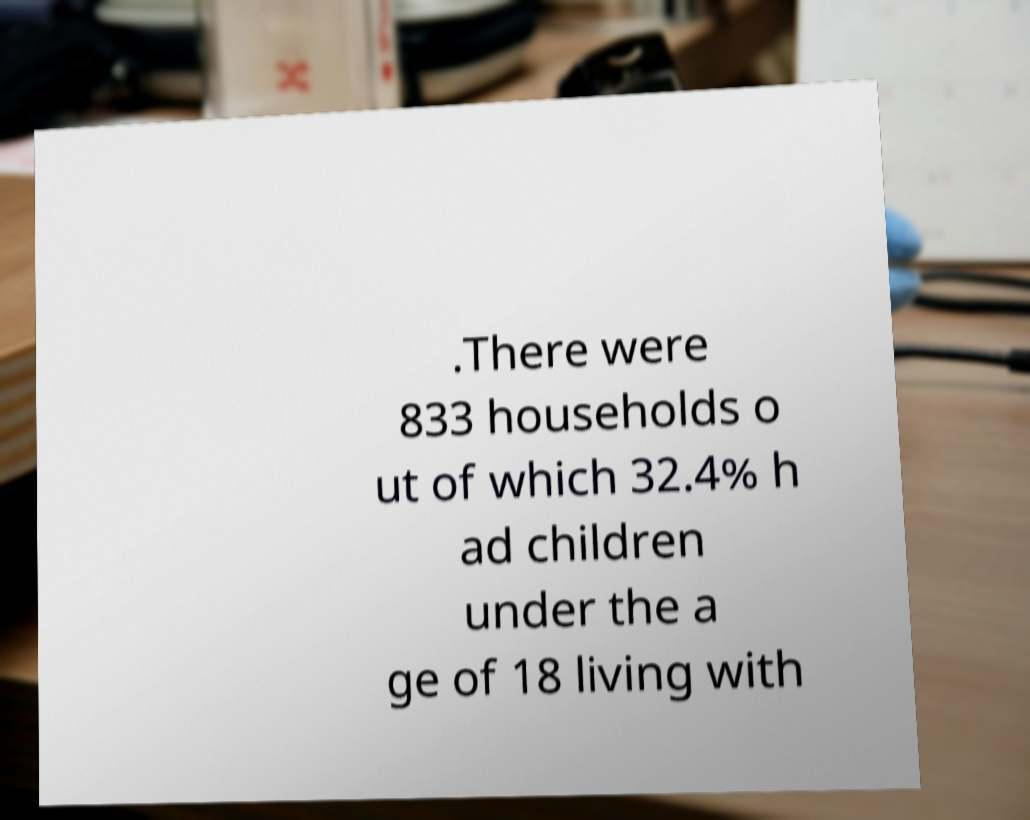Please identify and transcribe the text found in this image. .There were 833 households o ut of which 32.4% h ad children under the a ge of 18 living with 